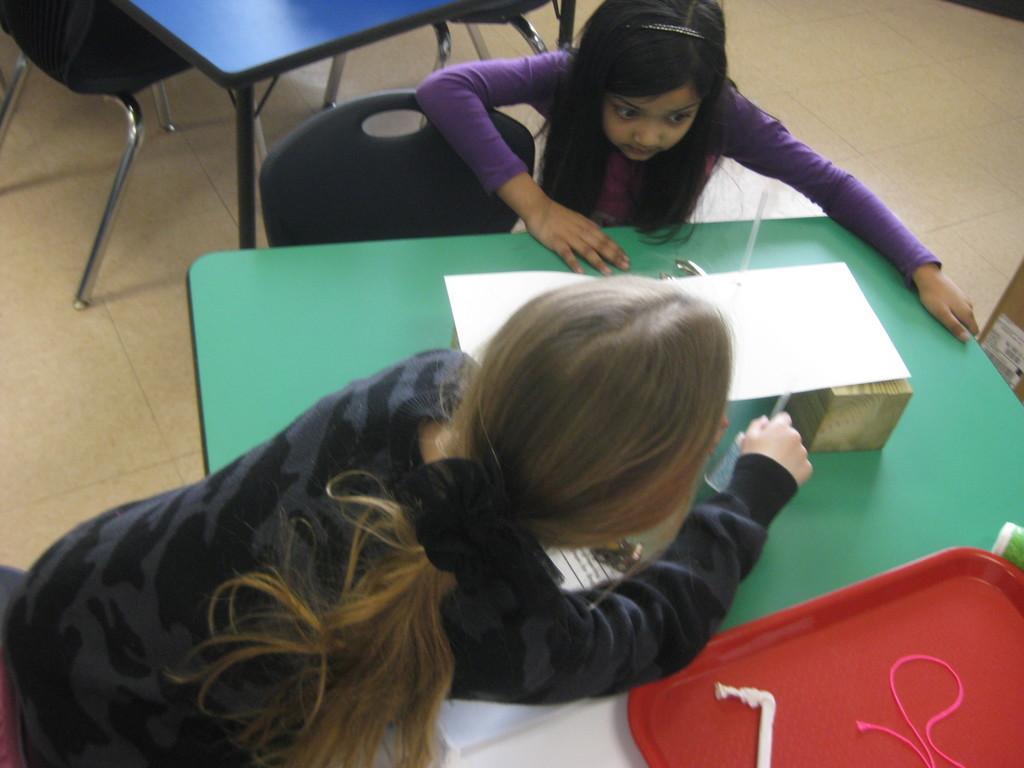How would you summarize this image in a sentence or two? In this picture we can see a two girl are play with paper and piece of wood which is placed on the green color table, Girl is wearing purple color t- shirt is watching under the paper and other girl beside there putting pen under the paper. Behind there is blue color table and black color chair. On the right side corner there is red tray and pink thread on it. 